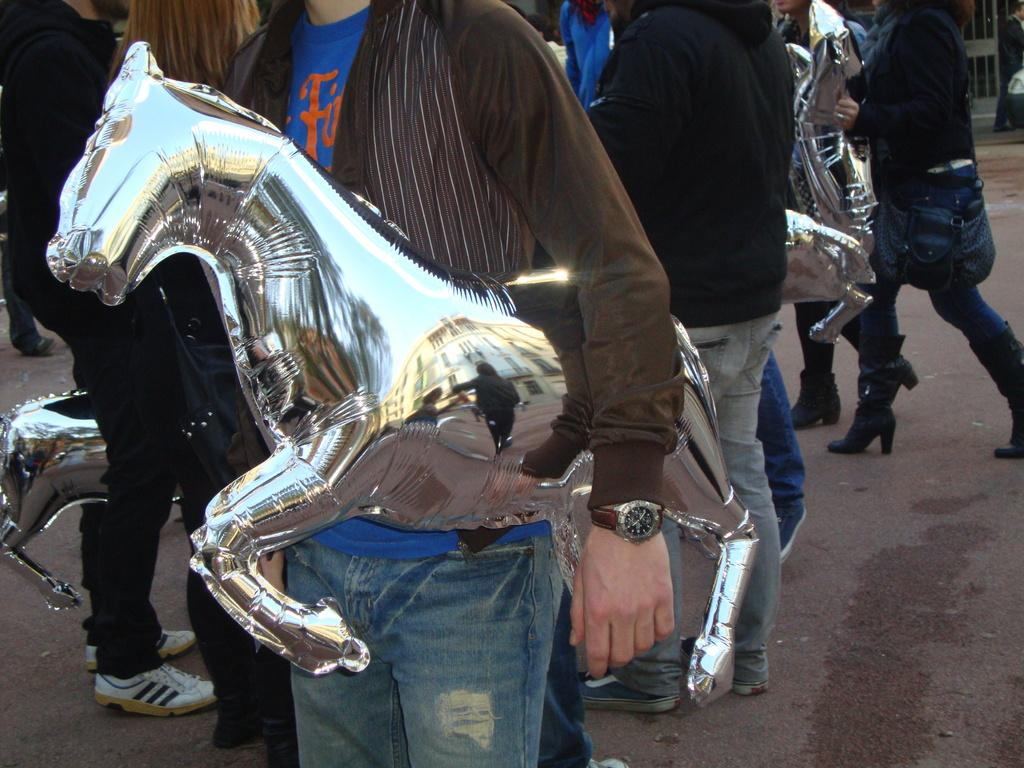Who or what can be seen in the image? There are people in the image. What else is present in the image besides people? There are toys and a road in the image. Can you tell me how many swings are visible in the image? There is no swing present in the image. What discovery was made by the people in the image? The image does not depict a discovery being made by the people. 